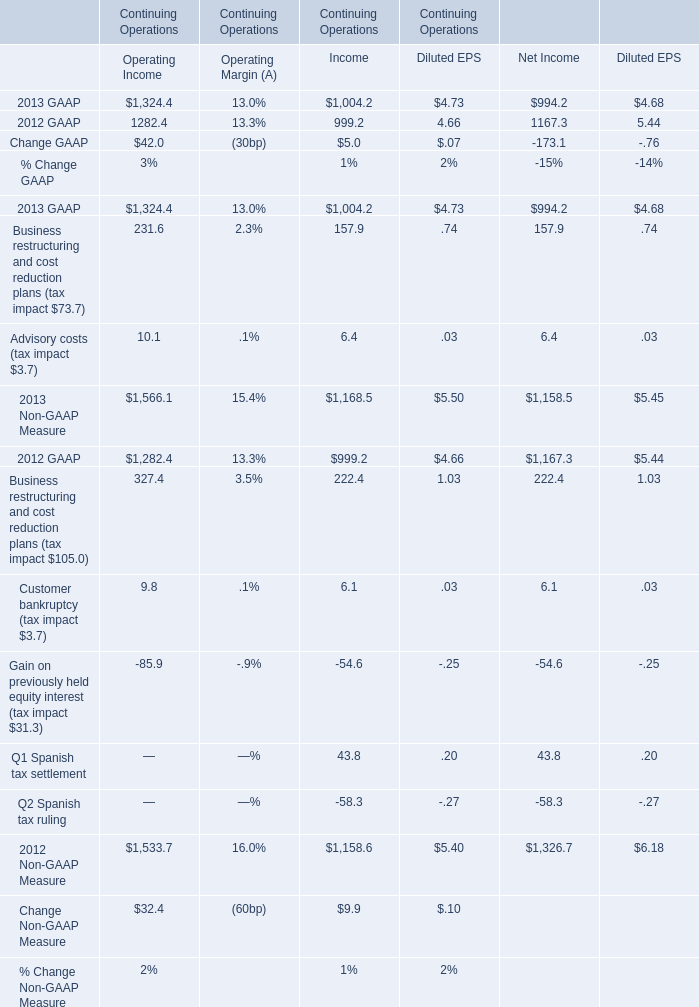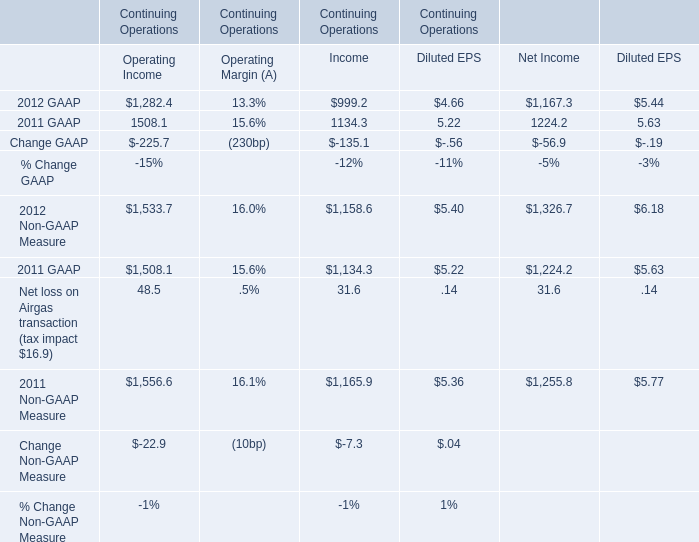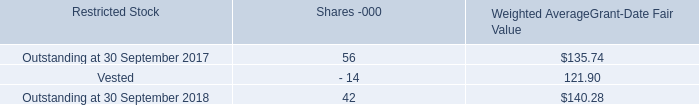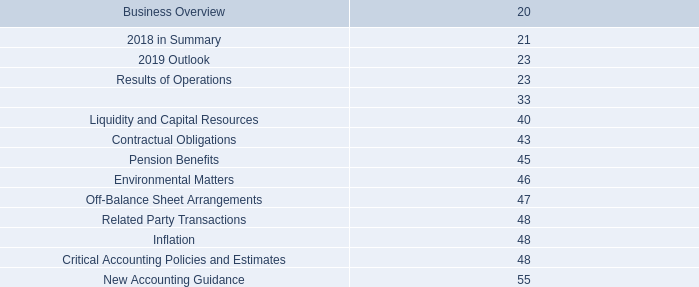what was the decrease observed in the total fair value of restricted stock that vested during 2017 and 2018? 
Computations: ((2.2 - 4.1) / 4.1)
Answer: -0.46341. 